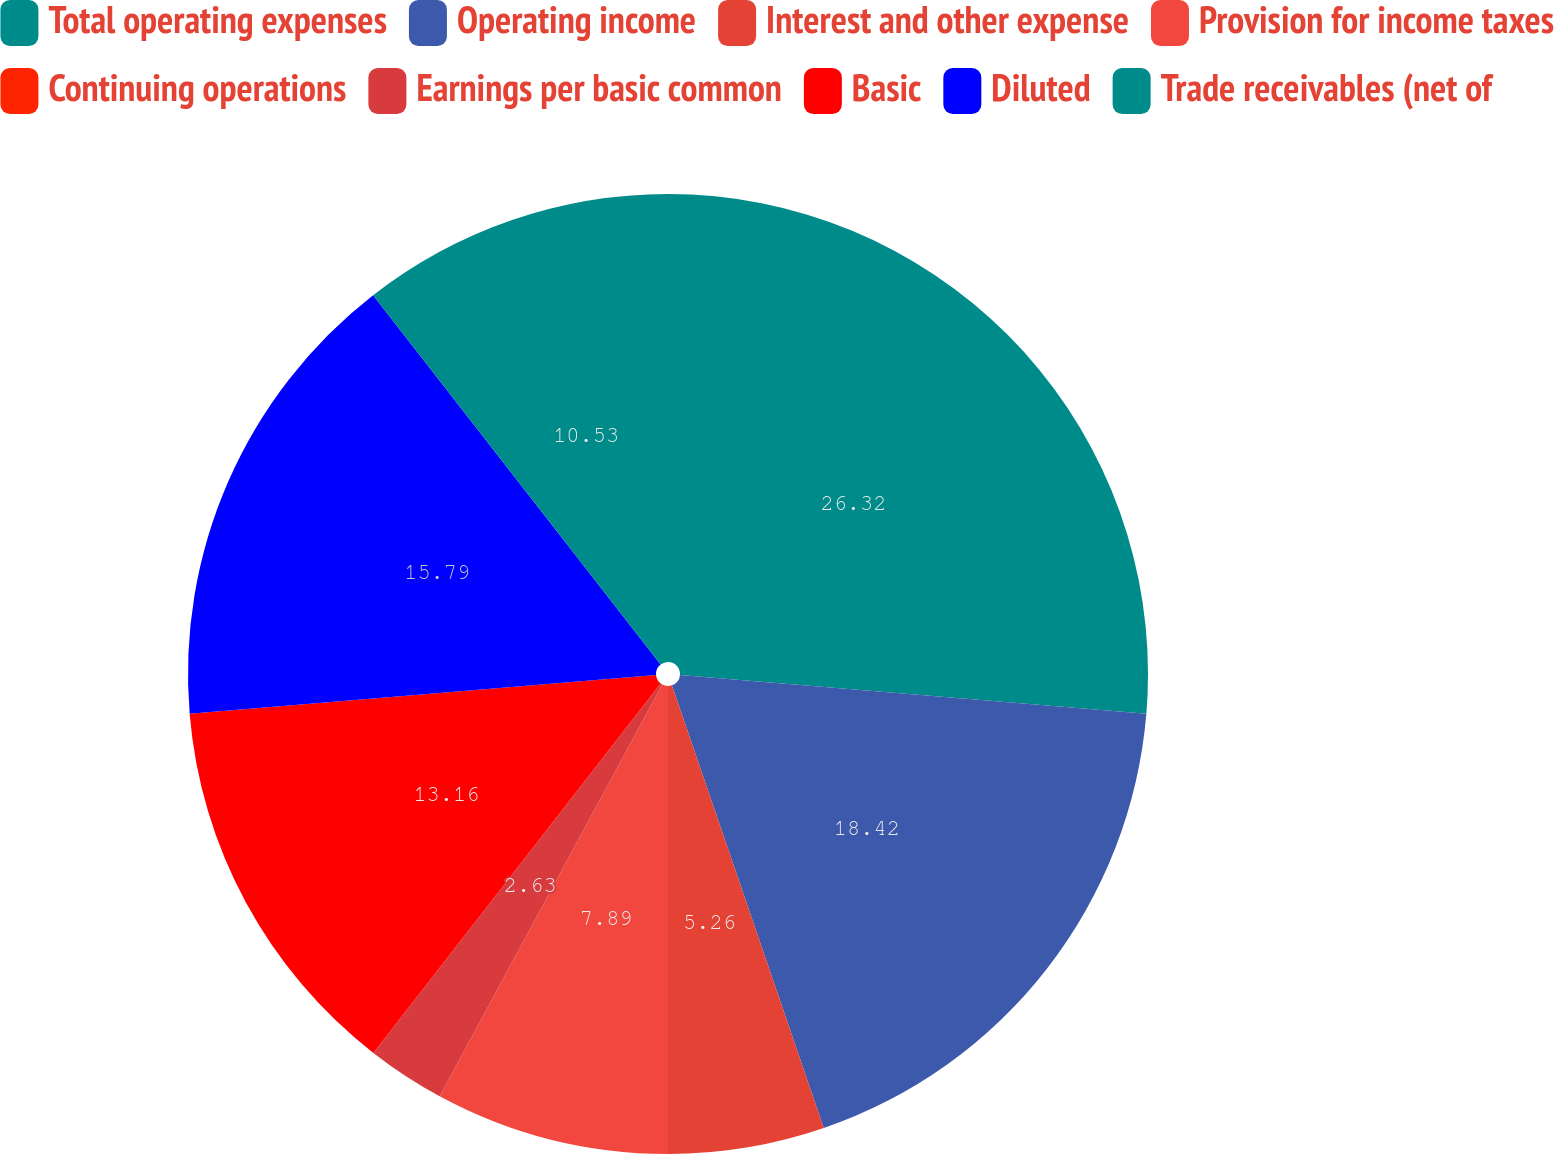Convert chart to OTSL. <chart><loc_0><loc_0><loc_500><loc_500><pie_chart><fcel>Total operating expenses<fcel>Operating income<fcel>Interest and other expense<fcel>Provision for income taxes<fcel>Continuing operations<fcel>Earnings per basic common<fcel>Basic<fcel>Diluted<fcel>Trade receivables (net of<nl><fcel>26.32%<fcel>18.42%<fcel>5.26%<fcel>7.89%<fcel>0.0%<fcel>2.63%<fcel>13.16%<fcel>15.79%<fcel>10.53%<nl></chart> 